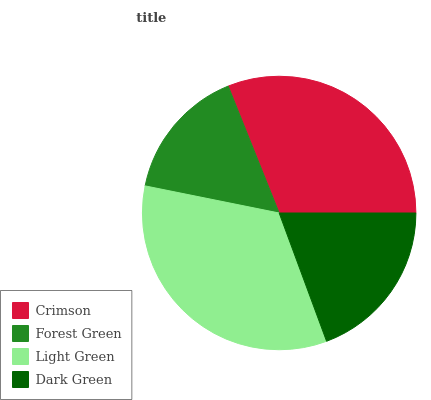Is Forest Green the minimum?
Answer yes or no. Yes. Is Light Green the maximum?
Answer yes or no. Yes. Is Light Green the minimum?
Answer yes or no. No. Is Forest Green the maximum?
Answer yes or no. No. Is Light Green greater than Forest Green?
Answer yes or no. Yes. Is Forest Green less than Light Green?
Answer yes or no. Yes. Is Forest Green greater than Light Green?
Answer yes or no. No. Is Light Green less than Forest Green?
Answer yes or no. No. Is Crimson the high median?
Answer yes or no. Yes. Is Dark Green the low median?
Answer yes or no. Yes. Is Forest Green the high median?
Answer yes or no. No. Is Forest Green the low median?
Answer yes or no. No. 